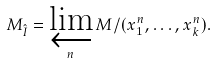Convert formula to latex. <formula><loc_0><loc_0><loc_500><loc_500>M _ { \hat { I } } = \varprojlim _ { n } M / ( x _ { 1 } ^ { n } , \dots , x _ { k } ^ { n } ) .</formula> 